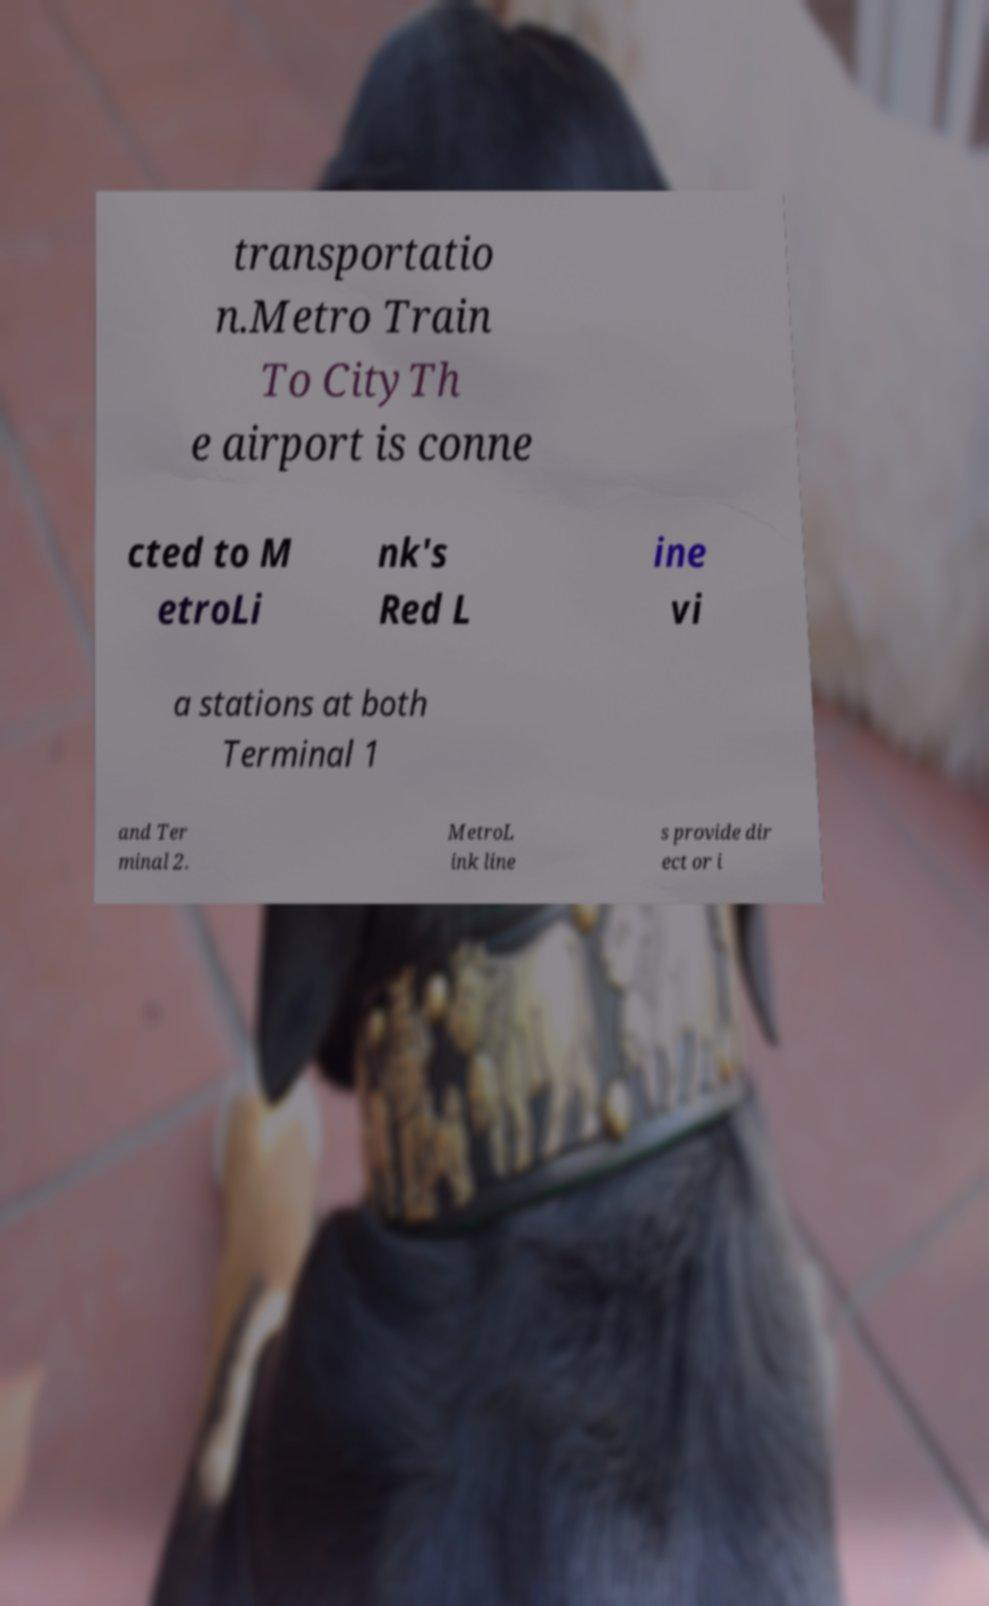Could you assist in decoding the text presented in this image and type it out clearly? transportatio n.Metro Train To CityTh e airport is conne cted to M etroLi nk's Red L ine vi a stations at both Terminal 1 and Ter minal 2. MetroL ink line s provide dir ect or i 